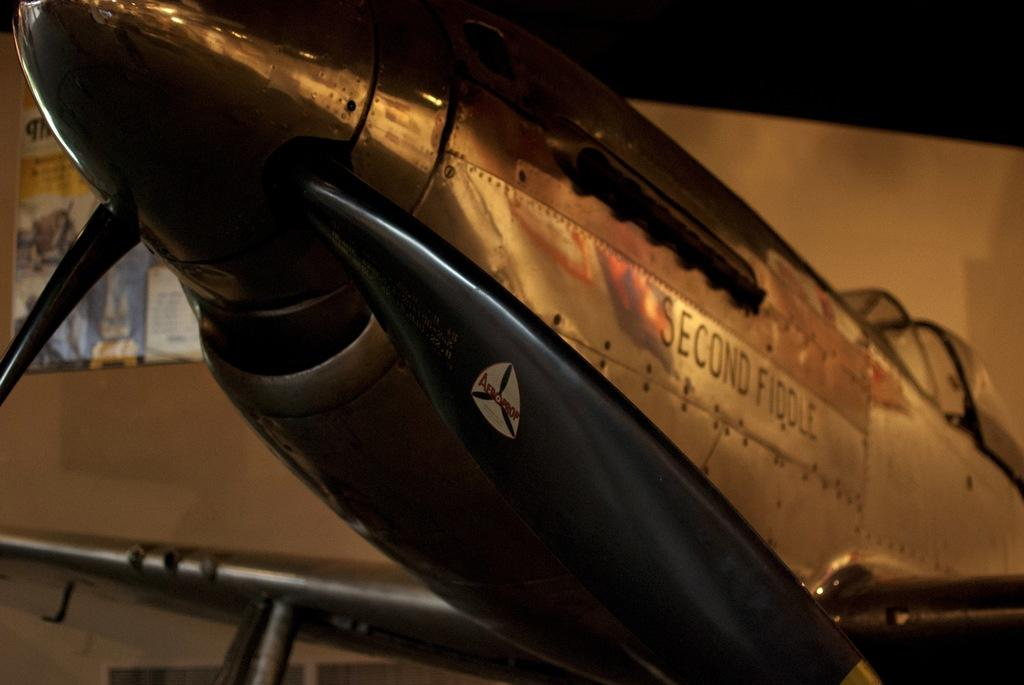<image>
Write a terse but informative summary of the picture. An Aeroprop Second Fiddle plane is shown in a museum type building. 